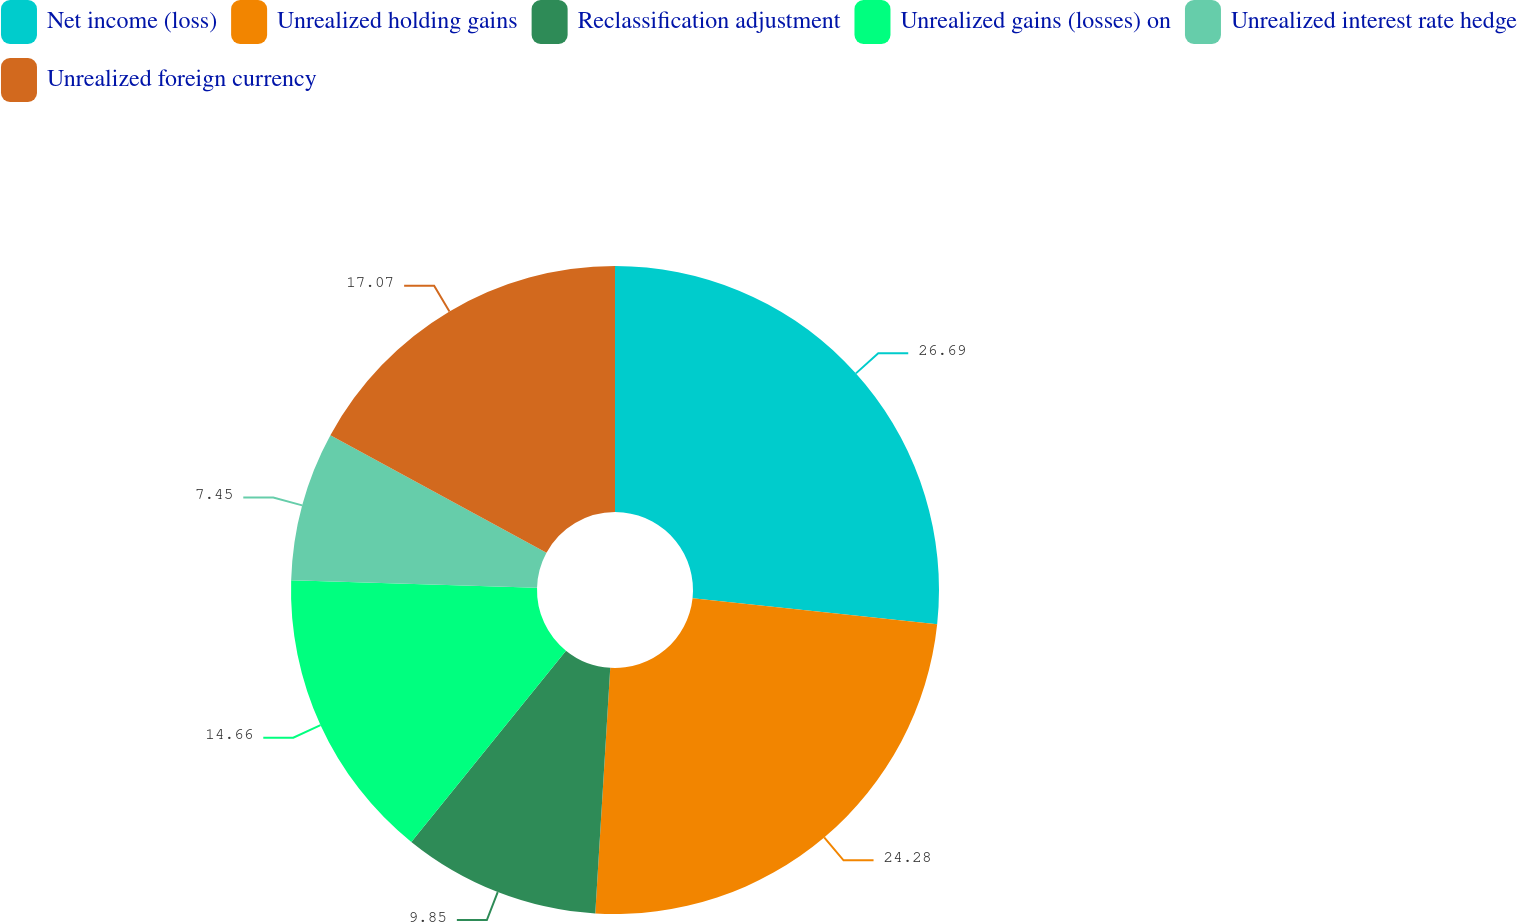Convert chart. <chart><loc_0><loc_0><loc_500><loc_500><pie_chart><fcel>Net income (loss)<fcel>Unrealized holding gains<fcel>Reclassification adjustment<fcel>Unrealized gains (losses) on<fcel>Unrealized interest rate hedge<fcel>Unrealized foreign currency<nl><fcel>26.69%<fcel>24.28%<fcel>9.85%<fcel>14.66%<fcel>7.45%<fcel>17.07%<nl></chart> 